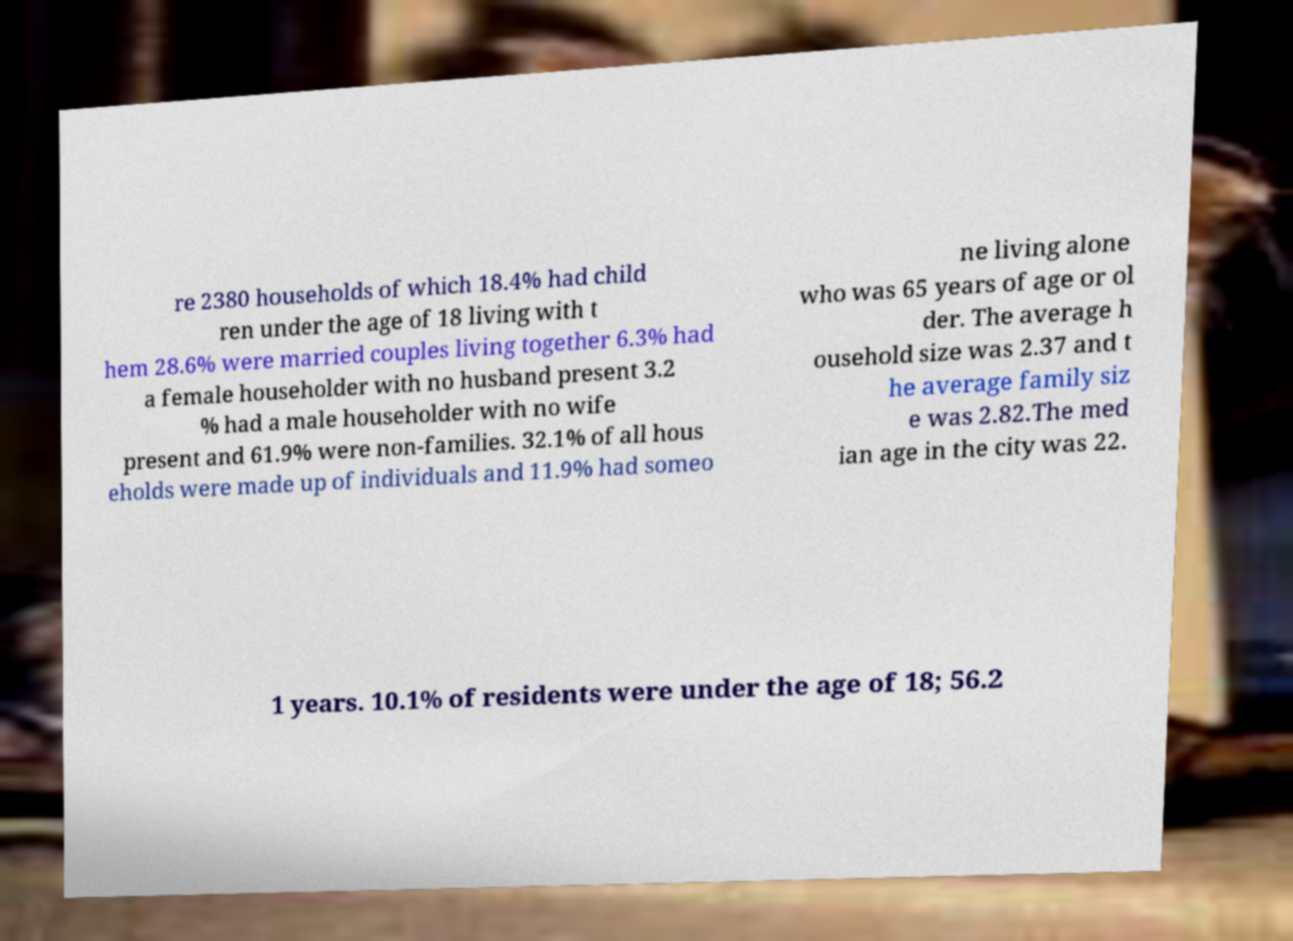Please identify and transcribe the text found in this image. re 2380 households of which 18.4% had child ren under the age of 18 living with t hem 28.6% were married couples living together 6.3% had a female householder with no husband present 3.2 % had a male householder with no wife present and 61.9% were non-families. 32.1% of all hous eholds were made up of individuals and 11.9% had someo ne living alone who was 65 years of age or ol der. The average h ousehold size was 2.37 and t he average family siz e was 2.82.The med ian age in the city was 22. 1 years. 10.1% of residents were under the age of 18; 56.2 